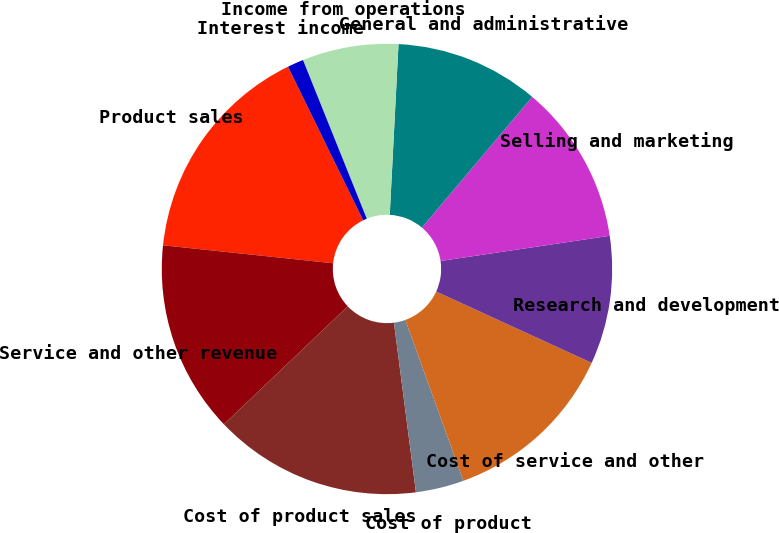<chart> <loc_0><loc_0><loc_500><loc_500><pie_chart><fcel>Product sales<fcel>Service and other revenue<fcel>Cost of product sales<fcel>Cost of product<fcel>Cost of service and other<fcel>Research and development<fcel>Selling and marketing<fcel>General and administrative<fcel>Income from operations<fcel>Interest income<nl><fcel>16.08%<fcel>13.79%<fcel>14.94%<fcel>3.46%<fcel>12.64%<fcel>9.2%<fcel>11.49%<fcel>10.34%<fcel>6.9%<fcel>1.16%<nl></chart> 